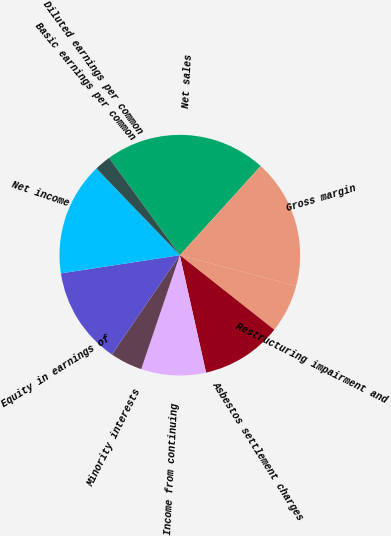<chart> <loc_0><loc_0><loc_500><loc_500><pie_chart><fcel>Net sales<fcel>Gross margin<fcel>Restructuring impairment and<fcel>Asbestos settlement charges<fcel>Income from continuing<fcel>Minority interests<fcel>Equity in earnings of<fcel>Net income<fcel>Basic earnings per common<fcel>Diluted earnings per common<nl><fcel>21.74%<fcel>17.39%<fcel>6.52%<fcel>10.87%<fcel>8.7%<fcel>4.35%<fcel>13.04%<fcel>15.22%<fcel>2.18%<fcel>0.0%<nl></chart> 